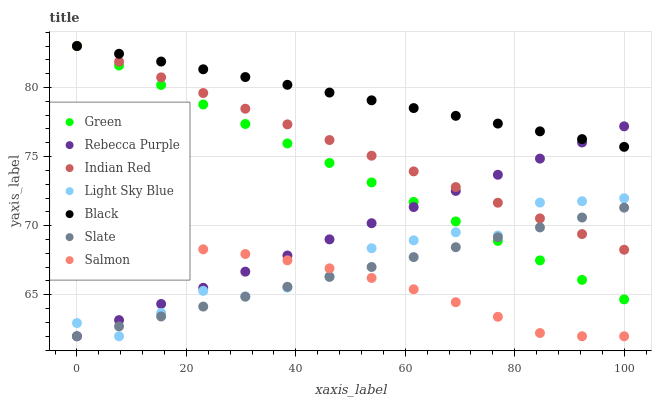Does Salmon have the minimum area under the curve?
Answer yes or no. Yes. Does Black have the maximum area under the curve?
Answer yes or no. Yes. Does Light Sky Blue have the minimum area under the curve?
Answer yes or no. No. Does Light Sky Blue have the maximum area under the curve?
Answer yes or no. No. Is Indian Red the smoothest?
Answer yes or no. Yes. Is Light Sky Blue the roughest?
Answer yes or no. Yes. Is Salmon the smoothest?
Answer yes or no. No. Is Salmon the roughest?
Answer yes or no. No. Does Slate have the lowest value?
Answer yes or no. Yes. Does Black have the lowest value?
Answer yes or no. No. Does Green have the highest value?
Answer yes or no. Yes. Does Light Sky Blue have the highest value?
Answer yes or no. No. Is Light Sky Blue less than Black?
Answer yes or no. Yes. Is Black greater than Light Sky Blue?
Answer yes or no. Yes. Does Indian Red intersect Light Sky Blue?
Answer yes or no. Yes. Is Indian Red less than Light Sky Blue?
Answer yes or no. No. Is Indian Red greater than Light Sky Blue?
Answer yes or no. No. Does Light Sky Blue intersect Black?
Answer yes or no. No. 